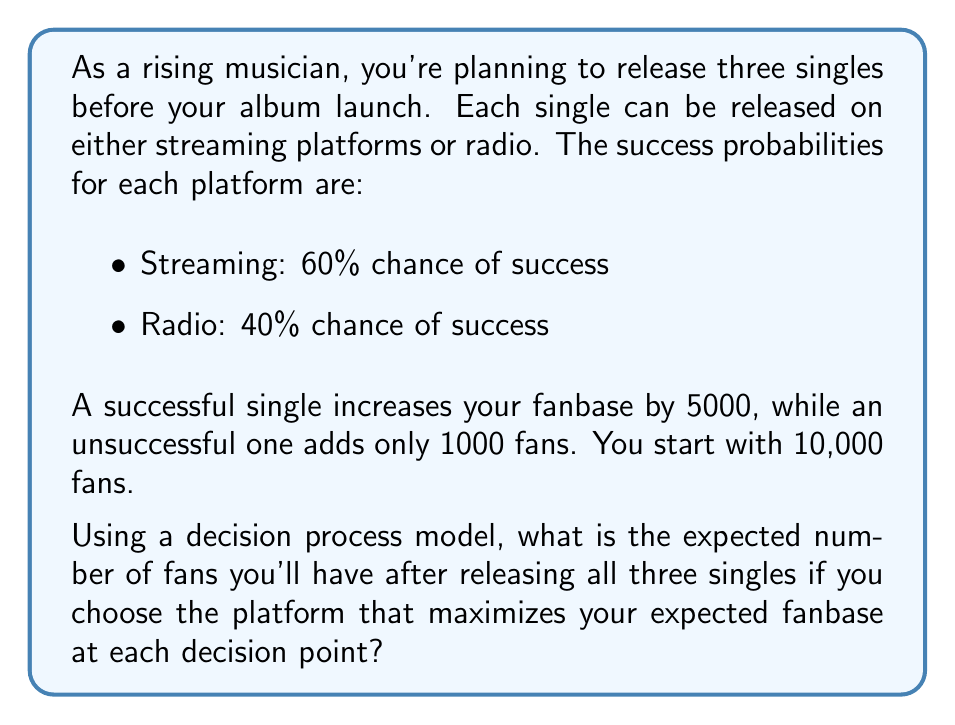Solve this math problem. Let's approach this step-by-step using a decision tree model:

1) We start with 10,000 fans. For each decision, we'll choose the option that gives the highest expected number of fans.

2) For the first single:
   Streaming: $0.6 \cdot 15000 + 0.4 \cdot 11000 = 13400$
   Radio: $0.4 \cdot 15000 + 0.6 \cdot 11000 = 12600$
   
   Choose streaming as it has a higher expected value.

3) Expected fans after first single: 13400

4) For the second single:
   Streaming: $0.6 \cdot (13400+5000) + 0.4 \cdot (13400+1000) = 17440$
   Radio: $0.4 \cdot (13400+5000) + 0.6 \cdot (13400+1000) = 15640$
   
   Choose streaming again.

5) Expected fans after second single: 17440

6) For the third single:
   Streaming: $0.6 \cdot (17440+5000) + 0.4 \cdot (17440+1000) = 21064$
   Radio: $0.4 \cdot (17440+5000) + 0.6 \cdot (17440+1000) = 19464$
   
   Choose streaming for the third time.

7) Final expected number of fans: 21064

This decision process always chooses streaming as it has the higher success probability and thus maximizes the expected fanbase at each decision point.
Answer: 21,064 fans 